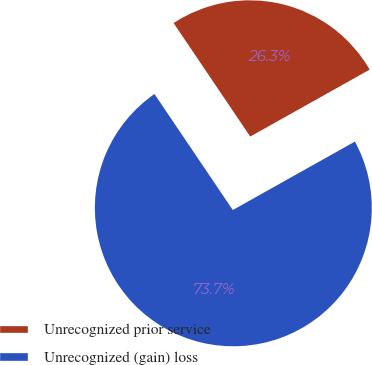<chart> <loc_0><loc_0><loc_500><loc_500><pie_chart><fcel>Unrecognized prior service<fcel>Unrecognized (gain) loss<nl><fcel>26.32%<fcel>73.68%<nl></chart> 